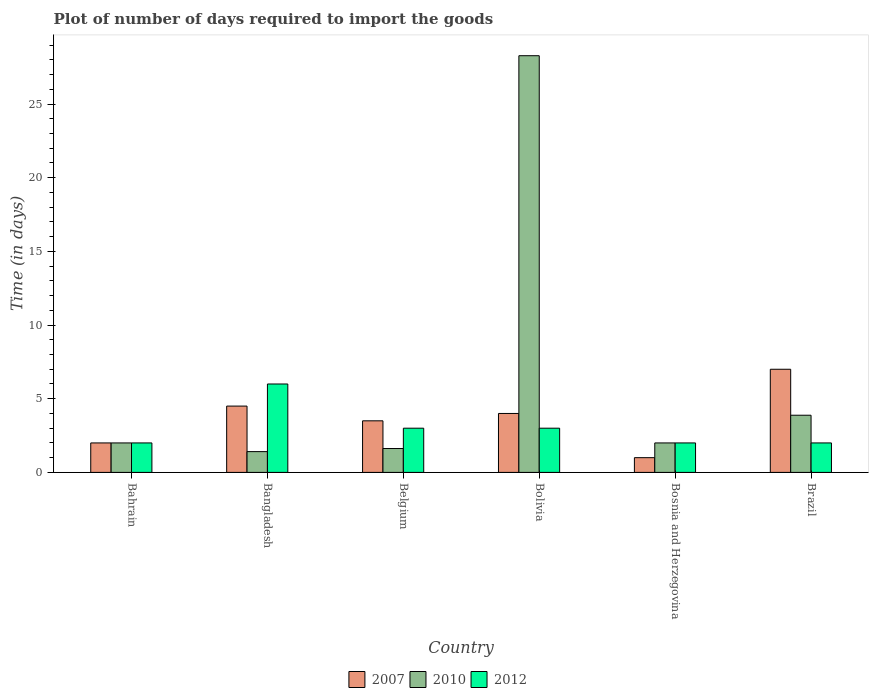How many different coloured bars are there?
Ensure brevity in your answer.  3. Are the number of bars on each tick of the X-axis equal?
Offer a terse response. Yes. What is the time required to import goods in 2010 in Bosnia and Herzegovina?
Provide a succinct answer. 2. Across all countries, what is the maximum time required to import goods in 2012?
Ensure brevity in your answer.  6. In which country was the time required to import goods in 2012 maximum?
Give a very brief answer. Bangladesh. In which country was the time required to import goods in 2007 minimum?
Provide a succinct answer. Bosnia and Herzegovina. What is the total time required to import goods in 2012 in the graph?
Your answer should be very brief. 18. What is the difference between the time required to import goods in 2010 in Bangladesh and that in Brazil?
Make the answer very short. -2.47. What is the difference between the time required to import goods in 2007 in Belgium and the time required to import goods in 2010 in Bolivia?
Keep it short and to the point. -24.78. What is the average time required to import goods in 2007 per country?
Keep it short and to the point. 3.67. What is the difference between the time required to import goods of/in 2007 and time required to import goods of/in 2010 in Bosnia and Herzegovina?
Your answer should be compact. -1. What is the ratio of the time required to import goods in 2012 in Bangladesh to that in Bosnia and Herzegovina?
Provide a succinct answer. 3. Is the time required to import goods in 2010 in Bahrain less than that in Brazil?
Offer a very short reply. Yes. Is the difference between the time required to import goods in 2007 in Bangladesh and Brazil greater than the difference between the time required to import goods in 2010 in Bangladesh and Brazil?
Keep it short and to the point. No. What is the difference between the highest and the second highest time required to import goods in 2010?
Offer a very short reply. -1.88. Is the sum of the time required to import goods in 2007 in Bangladesh and Bolivia greater than the maximum time required to import goods in 2012 across all countries?
Make the answer very short. Yes. How many bars are there?
Make the answer very short. 18. How many countries are there in the graph?
Provide a succinct answer. 6. Are the values on the major ticks of Y-axis written in scientific E-notation?
Your answer should be compact. No. Where does the legend appear in the graph?
Your answer should be very brief. Bottom center. How many legend labels are there?
Ensure brevity in your answer.  3. What is the title of the graph?
Provide a short and direct response. Plot of number of days required to import the goods. What is the label or title of the Y-axis?
Offer a very short reply. Time (in days). What is the Time (in days) of 2010 in Bahrain?
Make the answer very short. 2. What is the Time (in days) in 2012 in Bahrain?
Offer a very short reply. 2. What is the Time (in days) of 2010 in Bangladesh?
Give a very brief answer. 1.41. What is the Time (in days) in 2010 in Belgium?
Your answer should be compact. 1.62. What is the Time (in days) of 2007 in Bolivia?
Offer a very short reply. 4. What is the Time (in days) of 2010 in Bolivia?
Ensure brevity in your answer.  28.28. What is the Time (in days) in 2012 in Bosnia and Herzegovina?
Provide a succinct answer. 2. What is the Time (in days) in 2007 in Brazil?
Keep it short and to the point. 7. What is the Time (in days) of 2010 in Brazil?
Your response must be concise. 3.88. What is the Time (in days) of 2012 in Brazil?
Your answer should be compact. 2. Across all countries, what is the maximum Time (in days) in 2007?
Offer a terse response. 7. Across all countries, what is the maximum Time (in days) in 2010?
Offer a very short reply. 28.28. Across all countries, what is the maximum Time (in days) in 2012?
Your answer should be very brief. 6. Across all countries, what is the minimum Time (in days) in 2007?
Offer a terse response. 1. Across all countries, what is the minimum Time (in days) in 2010?
Make the answer very short. 1.41. Across all countries, what is the minimum Time (in days) of 2012?
Provide a short and direct response. 2. What is the total Time (in days) in 2007 in the graph?
Your response must be concise. 22. What is the total Time (in days) of 2010 in the graph?
Ensure brevity in your answer.  39.19. What is the difference between the Time (in days) of 2007 in Bahrain and that in Bangladesh?
Offer a terse response. -2.5. What is the difference between the Time (in days) of 2010 in Bahrain and that in Bangladesh?
Keep it short and to the point. 0.59. What is the difference between the Time (in days) in 2010 in Bahrain and that in Belgium?
Keep it short and to the point. 0.38. What is the difference between the Time (in days) of 2012 in Bahrain and that in Belgium?
Ensure brevity in your answer.  -1. What is the difference between the Time (in days) in 2007 in Bahrain and that in Bolivia?
Give a very brief answer. -2. What is the difference between the Time (in days) in 2010 in Bahrain and that in Bolivia?
Offer a very short reply. -26.28. What is the difference between the Time (in days) in 2012 in Bahrain and that in Bolivia?
Offer a terse response. -1. What is the difference between the Time (in days) in 2010 in Bahrain and that in Bosnia and Herzegovina?
Ensure brevity in your answer.  0. What is the difference between the Time (in days) of 2012 in Bahrain and that in Bosnia and Herzegovina?
Your answer should be compact. 0. What is the difference between the Time (in days) of 2007 in Bahrain and that in Brazil?
Provide a short and direct response. -5. What is the difference between the Time (in days) in 2010 in Bahrain and that in Brazil?
Provide a succinct answer. -1.88. What is the difference between the Time (in days) in 2012 in Bahrain and that in Brazil?
Your response must be concise. 0. What is the difference between the Time (in days) in 2007 in Bangladesh and that in Belgium?
Provide a succinct answer. 1. What is the difference between the Time (in days) of 2010 in Bangladesh and that in Belgium?
Keep it short and to the point. -0.21. What is the difference between the Time (in days) in 2007 in Bangladesh and that in Bolivia?
Offer a terse response. 0.5. What is the difference between the Time (in days) in 2010 in Bangladesh and that in Bolivia?
Your answer should be compact. -26.87. What is the difference between the Time (in days) of 2012 in Bangladesh and that in Bolivia?
Your answer should be very brief. 3. What is the difference between the Time (in days) of 2010 in Bangladesh and that in Bosnia and Herzegovina?
Offer a very short reply. -0.59. What is the difference between the Time (in days) in 2012 in Bangladesh and that in Bosnia and Herzegovina?
Make the answer very short. 4. What is the difference between the Time (in days) in 2010 in Bangladesh and that in Brazil?
Keep it short and to the point. -2.47. What is the difference between the Time (in days) in 2012 in Bangladesh and that in Brazil?
Ensure brevity in your answer.  4. What is the difference between the Time (in days) of 2010 in Belgium and that in Bolivia?
Make the answer very short. -26.66. What is the difference between the Time (in days) of 2010 in Belgium and that in Bosnia and Herzegovina?
Provide a succinct answer. -0.38. What is the difference between the Time (in days) of 2012 in Belgium and that in Bosnia and Herzegovina?
Ensure brevity in your answer.  1. What is the difference between the Time (in days) in 2010 in Belgium and that in Brazil?
Give a very brief answer. -2.26. What is the difference between the Time (in days) in 2010 in Bolivia and that in Bosnia and Herzegovina?
Ensure brevity in your answer.  26.28. What is the difference between the Time (in days) in 2007 in Bolivia and that in Brazil?
Offer a very short reply. -3. What is the difference between the Time (in days) in 2010 in Bolivia and that in Brazil?
Your answer should be very brief. 24.4. What is the difference between the Time (in days) in 2012 in Bolivia and that in Brazil?
Ensure brevity in your answer.  1. What is the difference between the Time (in days) of 2010 in Bosnia and Herzegovina and that in Brazil?
Ensure brevity in your answer.  -1.88. What is the difference between the Time (in days) of 2012 in Bosnia and Herzegovina and that in Brazil?
Offer a terse response. 0. What is the difference between the Time (in days) of 2007 in Bahrain and the Time (in days) of 2010 in Bangladesh?
Provide a succinct answer. 0.59. What is the difference between the Time (in days) in 2007 in Bahrain and the Time (in days) in 2012 in Bangladesh?
Ensure brevity in your answer.  -4. What is the difference between the Time (in days) in 2010 in Bahrain and the Time (in days) in 2012 in Bangladesh?
Keep it short and to the point. -4. What is the difference between the Time (in days) in 2007 in Bahrain and the Time (in days) in 2010 in Belgium?
Keep it short and to the point. 0.38. What is the difference between the Time (in days) in 2010 in Bahrain and the Time (in days) in 2012 in Belgium?
Your answer should be compact. -1. What is the difference between the Time (in days) in 2007 in Bahrain and the Time (in days) in 2010 in Bolivia?
Your response must be concise. -26.28. What is the difference between the Time (in days) of 2007 in Bahrain and the Time (in days) of 2012 in Bolivia?
Offer a terse response. -1. What is the difference between the Time (in days) of 2007 in Bahrain and the Time (in days) of 2010 in Bosnia and Herzegovina?
Your answer should be very brief. 0. What is the difference between the Time (in days) in 2007 in Bahrain and the Time (in days) in 2012 in Bosnia and Herzegovina?
Provide a short and direct response. 0. What is the difference between the Time (in days) of 2007 in Bahrain and the Time (in days) of 2010 in Brazil?
Offer a terse response. -1.88. What is the difference between the Time (in days) of 2007 in Bahrain and the Time (in days) of 2012 in Brazil?
Your response must be concise. 0. What is the difference between the Time (in days) of 2010 in Bahrain and the Time (in days) of 2012 in Brazil?
Your response must be concise. 0. What is the difference between the Time (in days) of 2007 in Bangladesh and the Time (in days) of 2010 in Belgium?
Your answer should be compact. 2.88. What is the difference between the Time (in days) of 2010 in Bangladesh and the Time (in days) of 2012 in Belgium?
Give a very brief answer. -1.59. What is the difference between the Time (in days) in 2007 in Bangladesh and the Time (in days) in 2010 in Bolivia?
Offer a terse response. -23.78. What is the difference between the Time (in days) of 2010 in Bangladesh and the Time (in days) of 2012 in Bolivia?
Ensure brevity in your answer.  -1.59. What is the difference between the Time (in days) in 2010 in Bangladesh and the Time (in days) in 2012 in Bosnia and Herzegovina?
Give a very brief answer. -0.59. What is the difference between the Time (in days) of 2007 in Bangladesh and the Time (in days) of 2010 in Brazil?
Provide a short and direct response. 0.62. What is the difference between the Time (in days) in 2007 in Bangladesh and the Time (in days) in 2012 in Brazil?
Your answer should be very brief. 2.5. What is the difference between the Time (in days) in 2010 in Bangladesh and the Time (in days) in 2012 in Brazil?
Your answer should be compact. -0.59. What is the difference between the Time (in days) of 2007 in Belgium and the Time (in days) of 2010 in Bolivia?
Your answer should be very brief. -24.78. What is the difference between the Time (in days) of 2007 in Belgium and the Time (in days) of 2012 in Bolivia?
Your response must be concise. 0.5. What is the difference between the Time (in days) in 2010 in Belgium and the Time (in days) in 2012 in Bolivia?
Ensure brevity in your answer.  -1.38. What is the difference between the Time (in days) in 2007 in Belgium and the Time (in days) in 2012 in Bosnia and Herzegovina?
Offer a terse response. 1.5. What is the difference between the Time (in days) in 2010 in Belgium and the Time (in days) in 2012 in Bosnia and Herzegovina?
Provide a succinct answer. -0.38. What is the difference between the Time (in days) in 2007 in Belgium and the Time (in days) in 2010 in Brazil?
Your answer should be compact. -0.38. What is the difference between the Time (in days) in 2007 in Belgium and the Time (in days) in 2012 in Brazil?
Provide a succinct answer. 1.5. What is the difference between the Time (in days) in 2010 in Belgium and the Time (in days) in 2012 in Brazil?
Your response must be concise. -0.38. What is the difference between the Time (in days) of 2007 in Bolivia and the Time (in days) of 2012 in Bosnia and Herzegovina?
Give a very brief answer. 2. What is the difference between the Time (in days) in 2010 in Bolivia and the Time (in days) in 2012 in Bosnia and Herzegovina?
Offer a terse response. 26.28. What is the difference between the Time (in days) in 2007 in Bolivia and the Time (in days) in 2010 in Brazil?
Offer a very short reply. 0.12. What is the difference between the Time (in days) of 2010 in Bolivia and the Time (in days) of 2012 in Brazil?
Provide a short and direct response. 26.28. What is the difference between the Time (in days) of 2007 in Bosnia and Herzegovina and the Time (in days) of 2010 in Brazil?
Ensure brevity in your answer.  -2.88. What is the difference between the Time (in days) of 2007 in Bosnia and Herzegovina and the Time (in days) of 2012 in Brazil?
Offer a terse response. -1. What is the difference between the Time (in days) of 2010 in Bosnia and Herzegovina and the Time (in days) of 2012 in Brazil?
Your answer should be very brief. 0. What is the average Time (in days) in 2007 per country?
Offer a very short reply. 3.67. What is the average Time (in days) in 2010 per country?
Provide a succinct answer. 6.53. What is the average Time (in days) of 2012 per country?
Your answer should be compact. 3. What is the difference between the Time (in days) of 2007 and Time (in days) of 2010 in Bahrain?
Your answer should be very brief. 0. What is the difference between the Time (in days) in 2010 and Time (in days) in 2012 in Bahrain?
Ensure brevity in your answer.  0. What is the difference between the Time (in days) in 2007 and Time (in days) in 2010 in Bangladesh?
Ensure brevity in your answer.  3.09. What is the difference between the Time (in days) in 2010 and Time (in days) in 2012 in Bangladesh?
Offer a very short reply. -4.59. What is the difference between the Time (in days) of 2007 and Time (in days) of 2010 in Belgium?
Make the answer very short. 1.88. What is the difference between the Time (in days) of 2010 and Time (in days) of 2012 in Belgium?
Your response must be concise. -1.38. What is the difference between the Time (in days) of 2007 and Time (in days) of 2010 in Bolivia?
Give a very brief answer. -24.28. What is the difference between the Time (in days) of 2007 and Time (in days) of 2012 in Bolivia?
Your answer should be compact. 1. What is the difference between the Time (in days) in 2010 and Time (in days) in 2012 in Bolivia?
Make the answer very short. 25.28. What is the difference between the Time (in days) of 2007 and Time (in days) of 2012 in Bosnia and Herzegovina?
Your response must be concise. -1. What is the difference between the Time (in days) of 2010 and Time (in days) of 2012 in Bosnia and Herzegovina?
Your response must be concise. 0. What is the difference between the Time (in days) in 2007 and Time (in days) in 2010 in Brazil?
Give a very brief answer. 3.12. What is the difference between the Time (in days) of 2007 and Time (in days) of 2012 in Brazil?
Your response must be concise. 5. What is the difference between the Time (in days) in 2010 and Time (in days) in 2012 in Brazil?
Ensure brevity in your answer.  1.88. What is the ratio of the Time (in days) in 2007 in Bahrain to that in Bangladesh?
Make the answer very short. 0.44. What is the ratio of the Time (in days) in 2010 in Bahrain to that in Bangladesh?
Offer a terse response. 1.42. What is the ratio of the Time (in days) in 2012 in Bahrain to that in Bangladesh?
Keep it short and to the point. 0.33. What is the ratio of the Time (in days) of 2007 in Bahrain to that in Belgium?
Your response must be concise. 0.57. What is the ratio of the Time (in days) in 2010 in Bahrain to that in Belgium?
Your answer should be very brief. 1.23. What is the ratio of the Time (in days) in 2007 in Bahrain to that in Bolivia?
Offer a terse response. 0.5. What is the ratio of the Time (in days) of 2010 in Bahrain to that in Bolivia?
Provide a succinct answer. 0.07. What is the ratio of the Time (in days) in 2007 in Bahrain to that in Bosnia and Herzegovina?
Offer a very short reply. 2. What is the ratio of the Time (in days) in 2012 in Bahrain to that in Bosnia and Herzegovina?
Offer a terse response. 1. What is the ratio of the Time (in days) in 2007 in Bahrain to that in Brazil?
Provide a succinct answer. 0.29. What is the ratio of the Time (in days) in 2010 in Bahrain to that in Brazil?
Offer a terse response. 0.52. What is the ratio of the Time (in days) in 2012 in Bahrain to that in Brazil?
Offer a very short reply. 1. What is the ratio of the Time (in days) in 2010 in Bangladesh to that in Belgium?
Keep it short and to the point. 0.87. What is the ratio of the Time (in days) of 2007 in Bangladesh to that in Bolivia?
Give a very brief answer. 1.12. What is the ratio of the Time (in days) in 2010 in Bangladesh to that in Bolivia?
Provide a short and direct response. 0.05. What is the ratio of the Time (in days) of 2012 in Bangladesh to that in Bolivia?
Provide a short and direct response. 2. What is the ratio of the Time (in days) of 2010 in Bangladesh to that in Bosnia and Herzegovina?
Ensure brevity in your answer.  0.7. What is the ratio of the Time (in days) of 2007 in Bangladesh to that in Brazil?
Provide a short and direct response. 0.64. What is the ratio of the Time (in days) of 2010 in Bangladesh to that in Brazil?
Your answer should be compact. 0.36. What is the ratio of the Time (in days) in 2012 in Bangladesh to that in Brazil?
Your answer should be compact. 3. What is the ratio of the Time (in days) in 2010 in Belgium to that in Bolivia?
Offer a terse response. 0.06. What is the ratio of the Time (in days) of 2012 in Belgium to that in Bolivia?
Your response must be concise. 1. What is the ratio of the Time (in days) in 2010 in Belgium to that in Bosnia and Herzegovina?
Your answer should be very brief. 0.81. What is the ratio of the Time (in days) of 2012 in Belgium to that in Bosnia and Herzegovina?
Provide a succinct answer. 1.5. What is the ratio of the Time (in days) of 2007 in Belgium to that in Brazil?
Provide a succinct answer. 0.5. What is the ratio of the Time (in days) in 2010 in Belgium to that in Brazil?
Your answer should be compact. 0.42. What is the ratio of the Time (in days) in 2012 in Belgium to that in Brazil?
Ensure brevity in your answer.  1.5. What is the ratio of the Time (in days) of 2007 in Bolivia to that in Bosnia and Herzegovina?
Your response must be concise. 4. What is the ratio of the Time (in days) of 2010 in Bolivia to that in Bosnia and Herzegovina?
Keep it short and to the point. 14.14. What is the ratio of the Time (in days) in 2012 in Bolivia to that in Bosnia and Herzegovina?
Offer a terse response. 1.5. What is the ratio of the Time (in days) in 2010 in Bolivia to that in Brazil?
Make the answer very short. 7.29. What is the ratio of the Time (in days) in 2007 in Bosnia and Herzegovina to that in Brazil?
Your answer should be very brief. 0.14. What is the ratio of the Time (in days) of 2010 in Bosnia and Herzegovina to that in Brazil?
Give a very brief answer. 0.52. What is the difference between the highest and the second highest Time (in days) in 2007?
Ensure brevity in your answer.  2.5. What is the difference between the highest and the second highest Time (in days) in 2010?
Provide a succinct answer. 24.4. What is the difference between the highest and the lowest Time (in days) in 2007?
Keep it short and to the point. 6. What is the difference between the highest and the lowest Time (in days) in 2010?
Your answer should be compact. 26.87. 